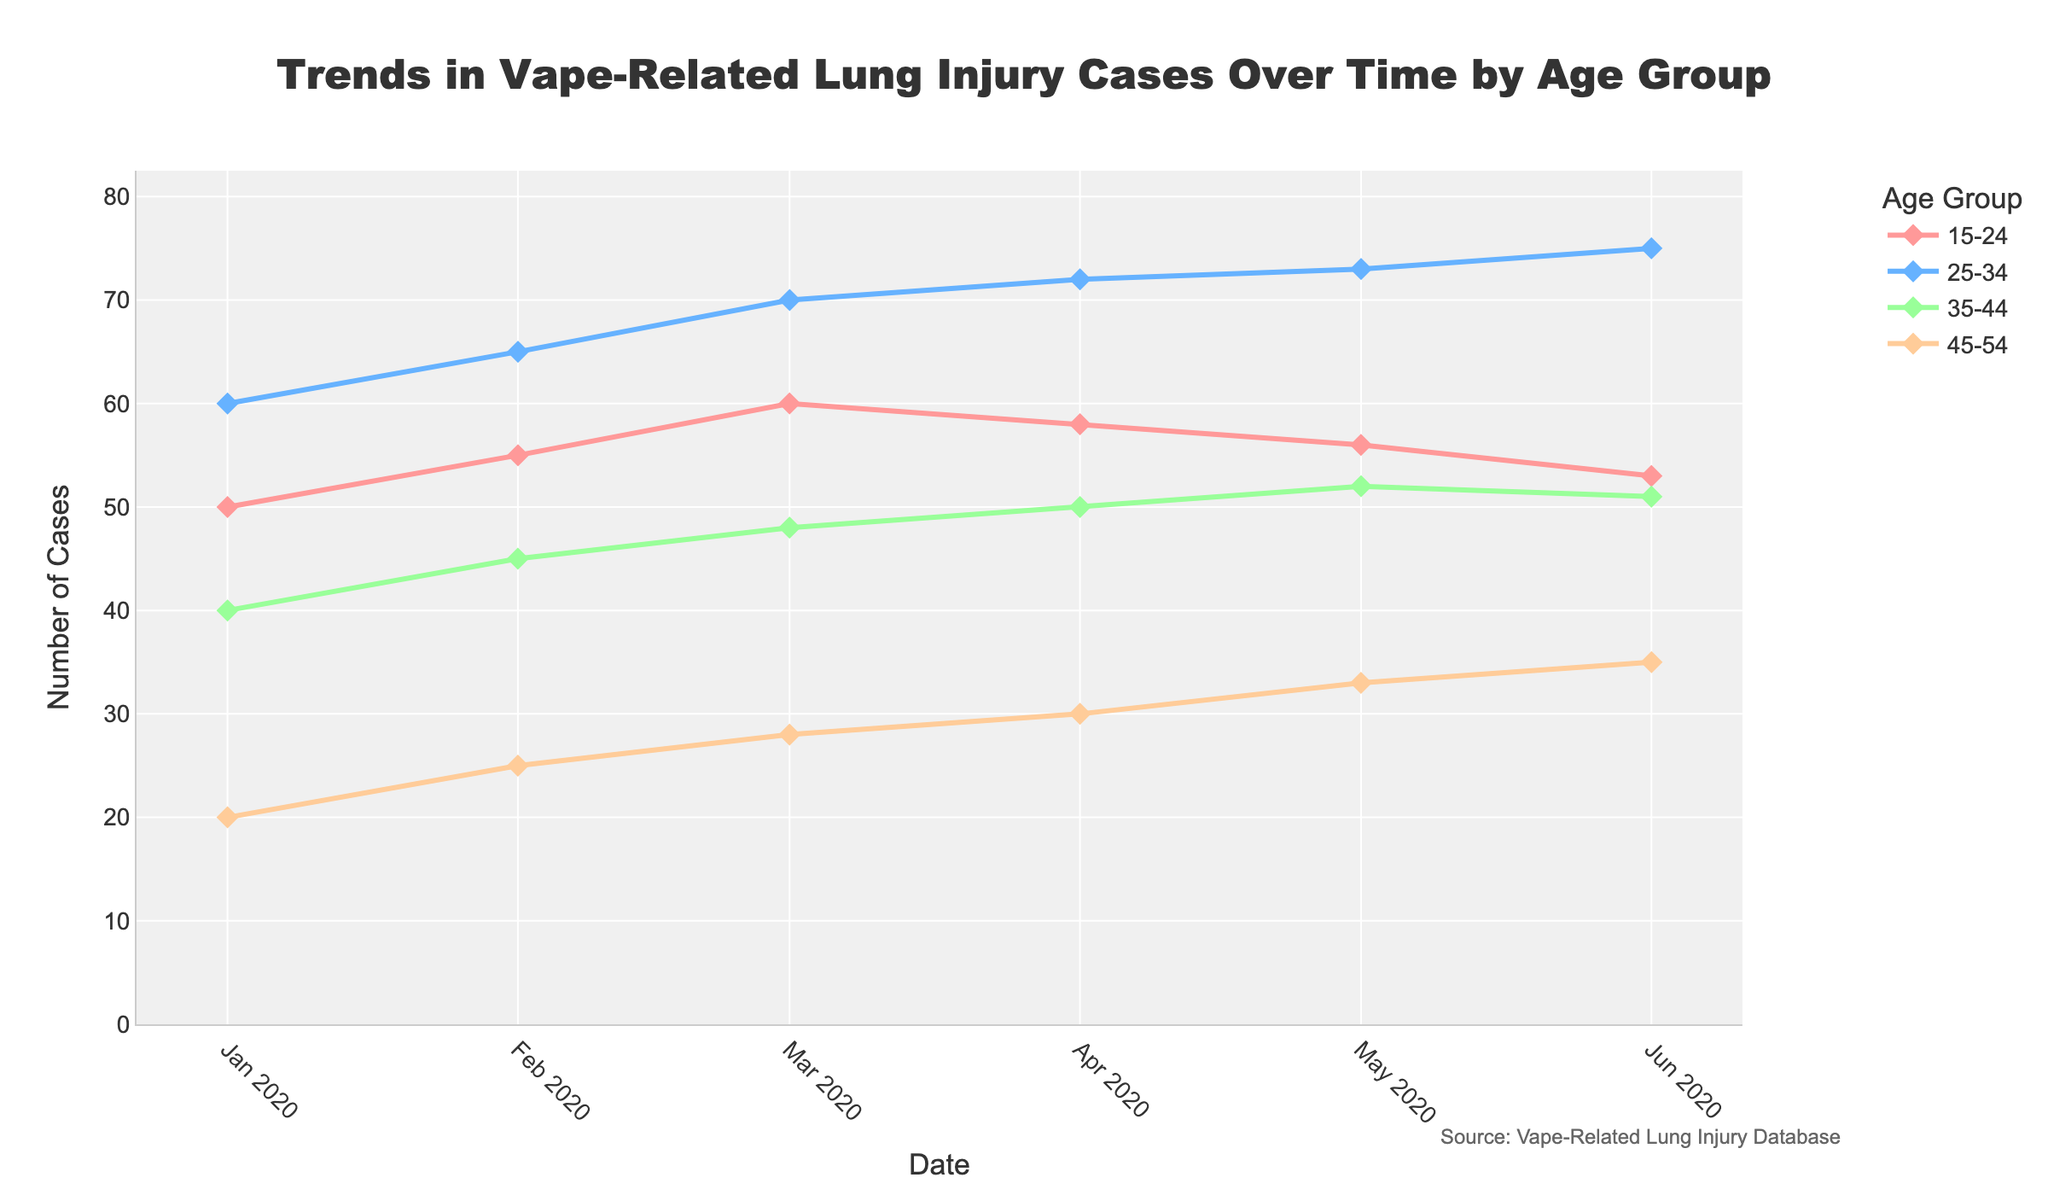What's the title of the figure? The title of the figure is prominently displayed at the top center. It reads "Trends in Vape-Related Lung Injury Cases Over Time by Age Group".
Answer: Trends in Vape-Related Lung Injury Cases Over Time by Age Group What is the highest number of cases reported for the age group 25-34? Trace the line for the 25-34 age group and identify the maximum point along the y-axis. The highest number of cases is 75, which occurred in June 2020.
Answer: 75 How many age groups are shown in the figure? Count the distinct lines in the plot, each of which corresponds to an age group. There are four distinct lines.
Answer: 4 What is the trend of the 15-24 age group from January to June 2020? Observe the line for the 15-24 age group from the leftmost point (January) to the rightmost point (June). The trend shows a gradual increase to 60 cases by March, followed by a slight decrease to 53 cases by June.
Answer: Gradual increase followed by a slight decrease Compare the number of cases in the 35-44 age group in February and May 2020. Which month had more cases? Look at the data points for February and May 2020 on the 35-44 age group line. February had 45 cases, and May had 52 cases. Hence, May had more cases.
Answer: May Which age group exhibited the most significant increase in the number of cases from January to June 2020? Compare the lines for each age group from January to June. The 25-34 age group shows the most substantial increase, going from 60 cases in January to 75 cases in June.
Answer: 25-34 What is the lowest number of cases reported in any age group and month? Identify the lowest point on the y-axis across all the lines. The lowest number of cases is 20, which occurred in January 2020 for the age group 45-54.
Answer: 20 Are there any age groups that show a consistent increase in cases over the six months? Analyze each age group's line for a consistent upward trend. The 25-34 age group shows a nearly consistent increase from 60 cases in January to 75 cases in June.
Answer: 25-34 In which month did the age group 45-54 have the highest number of cases? Follow the line for the age group 45-54 and identify the peak point. The highest number of cases, 35, occurred in June 2020.
Answer: June 2020 What is the overall trend observed among all age groups over the time period? Examine the general movement of all lines from January to June. The overall trend shows an increase in the number of cases across most age groups, with some fluctuations.
Answer: General increase with fluctuations 